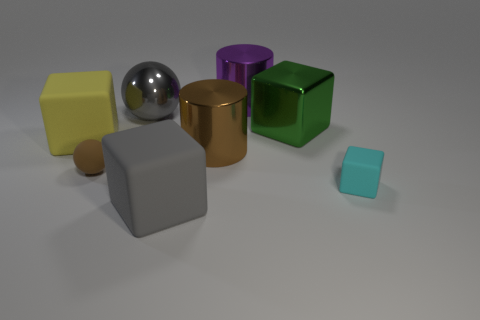There is a brown object on the right side of the object that is in front of the small cyan rubber thing; are there any big brown objects to the right of it?
Offer a terse response. No. What number of things are either blocks that are in front of the big green cube or metal things in front of the large ball?
Provide a short and direct response. 5. Is the cube left of the large gray metal thing made of the same material as the small sphere?
Offer a terse response. Yes. What material is the block that is on the right side of the gray block and left of the small cyan rubber cube?
Provide a short and direct response. Metal. What color is the cylinder behind the large cylinder that is in front of the green metallic object?
Give a very brief answer. Purple. What is the material of the small cyan object that is the same shape as the yellow thing?
Make the answer very short. Rubber. The small object that is to the left of the large rubber object to the right of the tiny rubber thing to the left of the large brown cylinder is what color?
Provide a succinct answer. Brown. How many things are small cyan balls or small cyan blocks?
Make the answer very short. 1. What number of gray matte things are the same shape as the small cyan rubber thing?
Your response must be concise. 1. Is the material of the large yellow cube the same as the big thing in front of the cyan thing?
Ensure brevity in your answer.  Yes. 